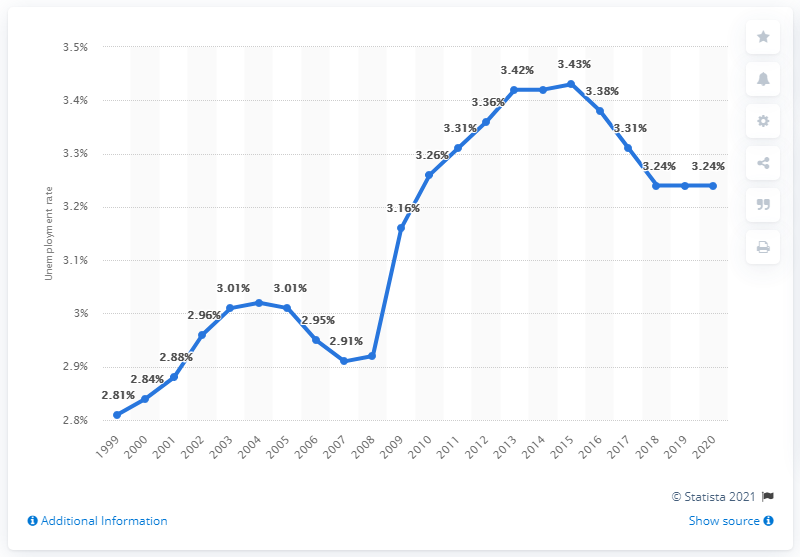Give some essential details in this illustration. In 2020, the unemployment rate in Mozambique was 3.24%. 